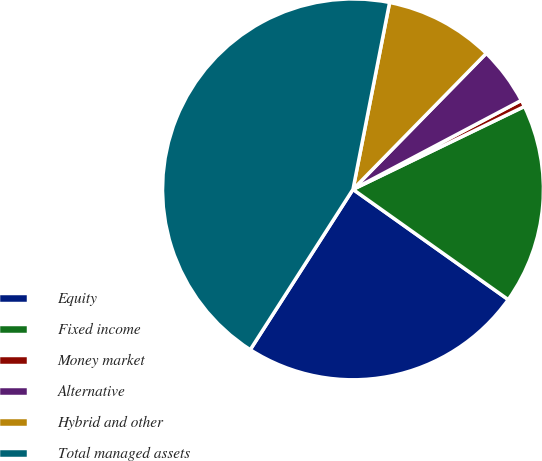<chart> <loc_0><loc_0><loc_500><loc_500><pie_chart><fcel>Equity<fcel>Fixed income<fcel>Money market<fcel>Alternative<fcel>Hybrid and other<fcel>Total managed assets<nl><fcel>24.24%<fcel>17.0%<fcel>0.57%<fcel>4.92%<fcel>9.26%<fcel>44.01%<nl></chart> 